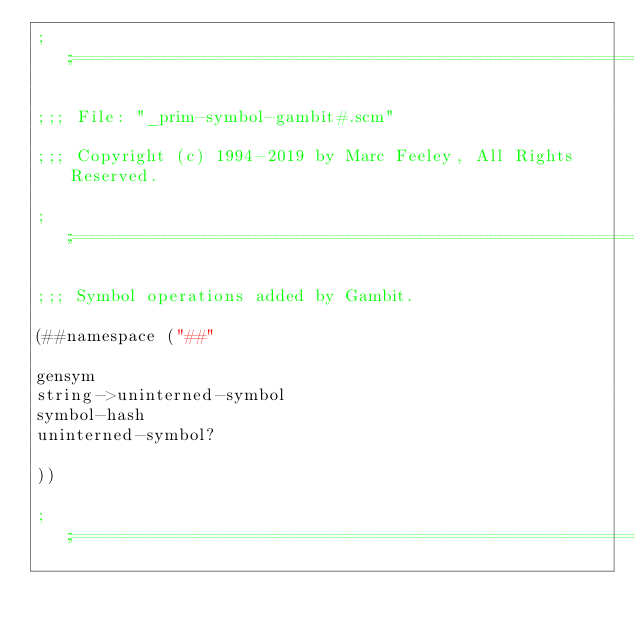Convert code to text. <code><loc_0><loc_0><loc_500><loc_500><_Scheme_>;;;============================================================================

;;; File: "_prim-symbol-gambit#.scm"

;;; Copyright (c) 1994-2019 by Marc Feeley, All Rights Reserved.

;;;============================================================================

;;; Symbol operations added by Gambit.

(##namespace ("##"

gensym
string->uninterned-symbol
symbol-hash
uninterned-symbol?

))

;;;============================================================================
</code> 